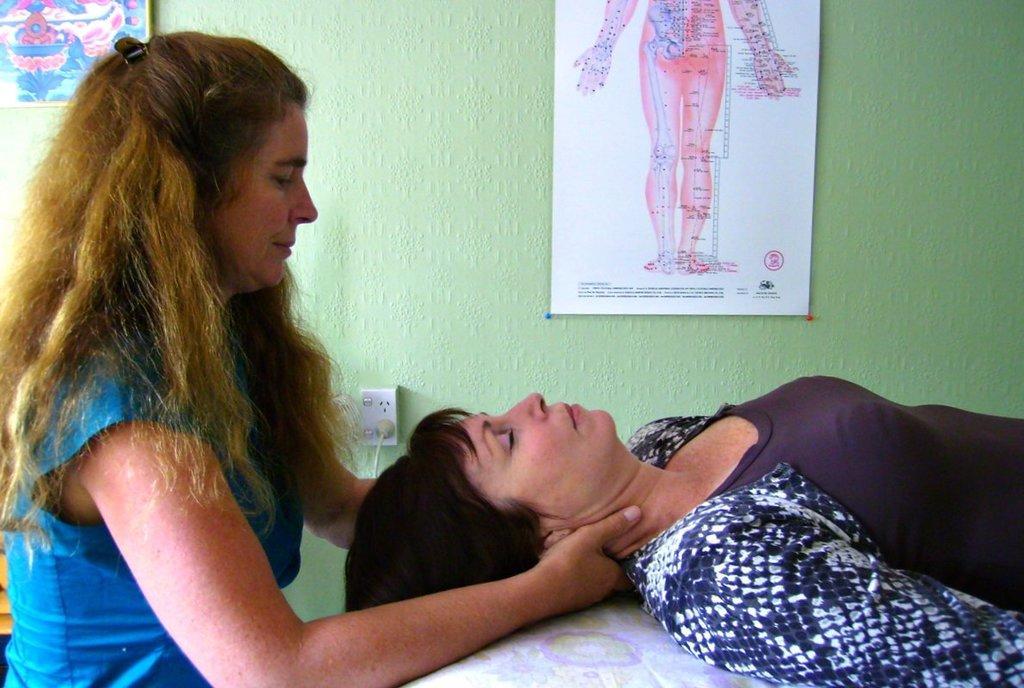Describe this image in one or two sentences. In this image I can see two women where the right one is lying. In the background I can see few boards on the green colour wall. 